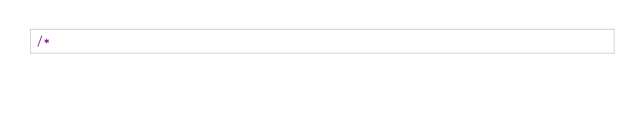Convert code to text. <code><loc_0><loc_0><loc_500><loc_500><_Java_>/*</code> 